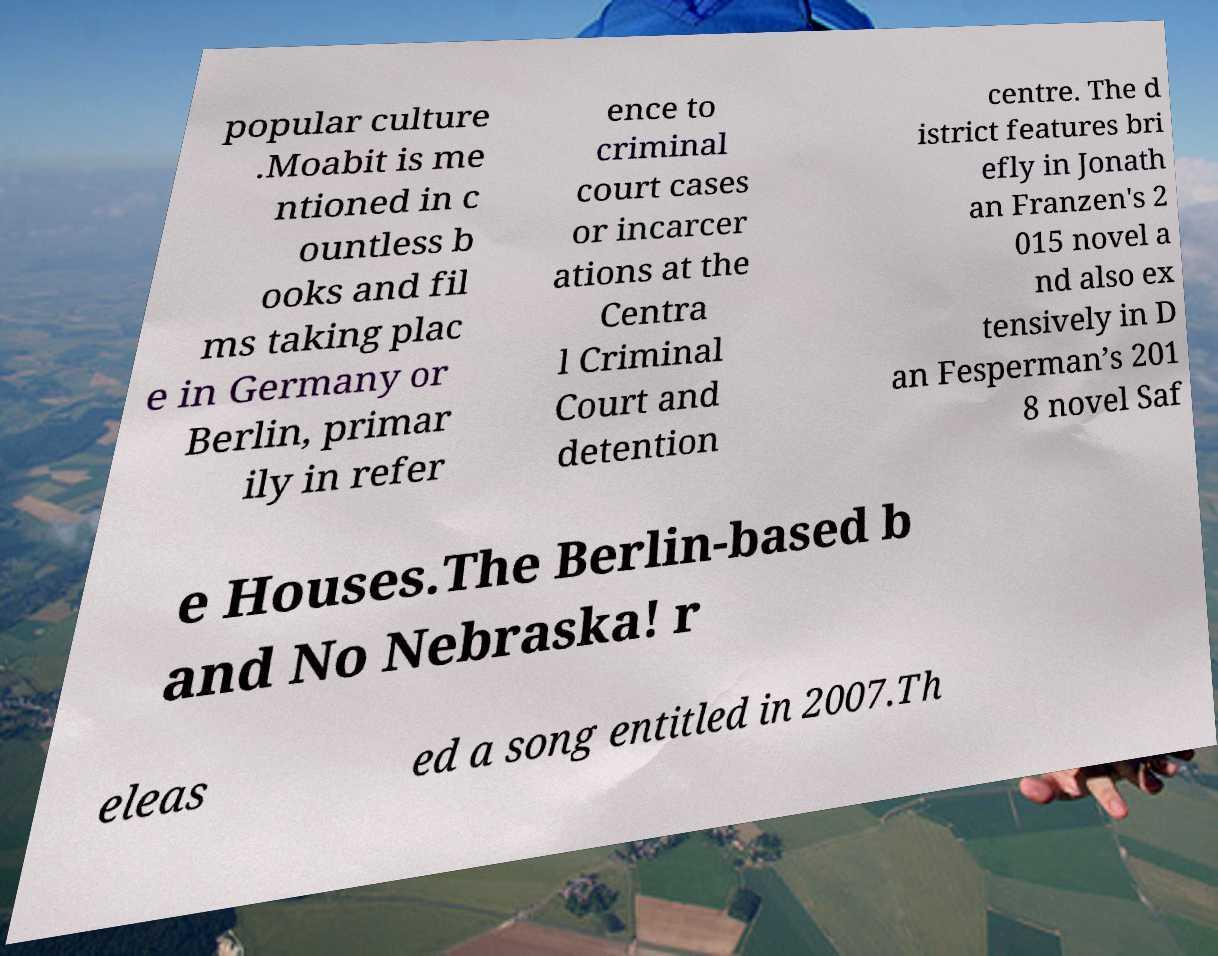There's text embedded in this image that I need extracted. Can you transcribe it verbatim? popular culture .Moabit is me ntioned in c ountless b ooks and fil ms taking plac e in Germany or Berlin, primar ily in refer ence to criminal court cases or incarcer ations at the Centra l Criminal Court and detention centre. The d istrict features bri efly in Jonath an Franzen's 2 015 novel a nd also ex tensively in D an Fesperman’s 201 8 novel Saf e Houses.The Berlin-based b and No Nebraska! r eleas ed a song entitled in 2007.Th 